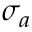<formula> <loc_0><loc_0><loc_500><loc_500>\sigma _ { a }</formula> 